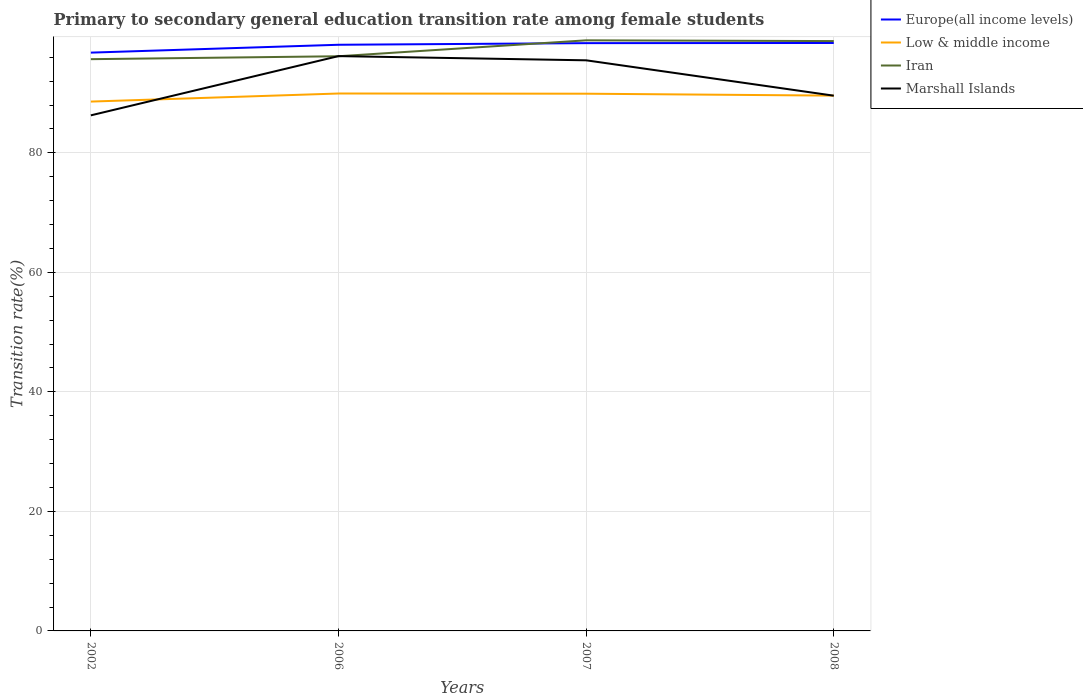How many different coloured lines are there?
Offer a very short reply. 4. Does the line corresponding to Marshall Islands intersect with the line corresponding to Low & middle income?
Keep it short and to the point. Yes. Across all years, what is the maximum transition rate in Marshall Islands?
Keep it short and to the point. 86.27. What is the total transition rate in Europe(all income levels) in the graph?
Offer a very short reply. -0.3. What is the difference between the highest and the second highest transition rate in Iran?
Give a very brief answer. 3.15. What is the difference between the highest and the lowest transition rate in Marshall Islands?
Your answer should be very brief. 2. Is the transition rate in Europe(all income levels) strictly greater than the transition rate in Iran over the years?
Your answer should be compact. No. How many years are there in the graph?
Offer a terse response. 4. Are the values on the major ticks of Y-axis written in scientific E-notation?
Give a very brief answer. No. How are the legend labels stacked?
Make the answer very short. Vertical. What is the title of the graph?
Provide a succinct answer. Primary to secondary general education transition rate among female students. What is the label or title of the Y-axis?
Provide a short and direct response. Transition rate(%). What is the Transition rate(%) in Europe(all income levels) in 2002?
Your answer should be compact. 96.77. What is the Transition rate(%) in Low & middle income in 2002?
Offer a terse response. 88.58. What is the Transition rate(%) of Iran in 2002?
Offer a very short reply. 95.68. What is the Transition rate(%) in Marshall Islands in 2002?
Provide a succinct answer. 86.27. What is the Transition rate(%) in Europe(all income levels) in 2006?
Offer a very short reply. 98.08. What is the Transition rate(%) in Low & middle income in 2006?
Keep it short and to the point. 89.93. What is the Transition rate(%) of Iran in 2006?
Give a very brief answer. 96.16. What is the Transition rate(%) in Marshall Islands in 2006?
Ensure brevity in your answer.  96.19. What is the Transition rate(%) of Europe(all income levels) in 2007?
Keep it short and to the point. 98.36. What is the Transition rate(%) in Low & middle income in 2007?
Keep it short and to the point. 89.89. What is the Transition rate(%) in Iran in 2007?
Your answer should be very brief. 98.83. What is the Transition rate(%) of Marshall Islands in 2007?
Your answer should be compact. 95.48. What is the Transition rate(%) of Europe(all income levels) in 2008?
Ensure brevity in your answer.  98.38. What is the Transition rate(%) in Low & middle income in 2008?
Your response must be concise. 89.58. What is the Transition rate(%) in Iran in 2008?
Offer a terse response. 98.7. What is the Transition rate(%) in Marshall Islands in 2008?
Provide a succinct answer. 89.57. Across all years, what is the maximum Transition rate(%) of Europe(all income levels)?
Your answer should be compact. 98.38. Across all years, what is the maximum Transition rate(%) of Low & middle income?
Keep it short and to the point. 89.93. Across all years, what is the maximum Transition rate(%) of Iran?
Provide a short and direct response. 98.83. Across all years, what is the maximum Transition rate(%) of Marshall Islands?
Your answer should be very brief. 96.19. Across all years, what is the minimum Transition rate(%) in Europe(all income levels)?
Your response must be concise. 96.77. Across all years, what is the minimum Transition rate(%) of Low & middle income?
Provide a short and direct response. 88.58. Across all years, what is the minimum Transition rate(%) in Iran?
Provide a short and direct response. 95.68. Across all years, what is the minimum Transition rate(%) of Marshall Islands?
Give a very brief answer. 86.27. What is the total Transition rate(%) in Europe(all income levels) in the graph?
Keep it short and to the point. 391.6. What is the total Transition rate(%) in Low & middle income in the graph?
Ensure brevity in your answer.  357.98. What is the total Transition rate(%) of Iran in the graph?
Offer a very short reply. 389.37. What is the total Transition rate(%) of Marshall Islands in the graph?
Offer a terse response. 367.51. What is the difference between the Transition rate(%) in Europe(all income levels) in 2002 and that in 2006?
Keep it short and to the point. -1.31. What is the difference between the Transition rate(%) in Low & middle income in 2002 and that in 2006?
Offer a terse response. -1.35. What is the difference between the Transition rate(%) in Iran in 2002 and that in 2006?
Offer a terse response. -0.49. What is the difference between the Transition rate(%) in Marshall Islands in 2002 and that in 2006?
Ensure brevity in your answer.  -9.91. What is the difference between the Transition rate(%) of Europe(all income levels) in 2002 and that in 2007?
Your answer should be very brief. -1.59. What is the difference between the Transition rate(%) in Low & middle income in 2002 and that in 2007?
Make the answer very short. -1.32. What is the difference between the Transition rate(%) in Iran in 2002 and that in 2007?
Keep it short and to the point. -3.15. What is the difference between the Transition rate(%) of Marshall Islands in 2002 and that in 2007?
Keep it short and to the point. -9.21. What is the difference between the Transition rate(%) in Europe(all income levels) in 2002 and that in 2008?
Provide a succinct answer. -1.61. What is the difference between the Transition rate(%) in Low & middle income in 2002 and that in 2008?
Give a very brief answer. -1. What is the difference between the Transition rate(%) of Iran in 2002 and that in 2008?
Offer a very short reply. -3.03. What is the difference between the Transition rate(%) of Marshall Islands in 2002 and that in 2008?
Your answer should be compact. -3.29. What is the difference between the Transition rate(%) of Europe(all income levels) in 2006 and that in 2007?
Your response must be concise. -0.27. What is the difference between the Transition rate(%) in Low & middle income in 2006 and that in 2007?
Provide a succinct answer. 0.03. What is the difference between the Transition rate(%) of Iran in 2006 and that in 2007?
Ensure brevity in your answer.  -2.66. What is the difference between the Transition rate(%) of Marshall Islands in 2006 and that in 2007?
Provide a succinct answer. 0.7. What is the difference between the Transition rate(%) of Europe(all income levels) in 2006 and that in 2008?
Your response must be concise. -0.3. What is the difference between the Transition rate(%) in Low & middle income in 2006 and that in 2008?
Make the answer very short. 0.35. What is the difference between the Transition rate(%) in Iran in 2006 and that in 2008?
Provide a short and direct response. -2.54. What is the difference between the Transition rate(%) in Marshall Islands in 2006 and that in 2008?
Give a very brief answer. 6.62. What is the difference between the Transition rate(%) of Europe(all income levels) in 2007 and that in 2008?
Offer a very short reply. -0.03. What is the difference between the Transition rate(%) of Low & middle income in 2007 and that in 2008?
Your answer should be compact. 0.32. What is the difference between the Transition rate(%) of Iran in 2007 and that in 2008?
Provide a succinct answer. 0.13. What is the difference between the Transition rate(%) in Marshall Islands in 2007 and that in 2008?
Offer a terse response. 5.92. What is the difference between the Transition rate(%) of Europe(all income levels) in 2002 and the Transition rate(%) of Low & middle income in 2006?
Your answer should be compact. 6.84. What is the difference between the Transition rate(%) of Europe(all income levels) in 2002 and the Transition rate(%) of Iran in 2006?
Ensure brevity in your answer.  0.61. What is the difference between the Transition rate(%) of Europe(all income levels) in 2002 and the Transition rate(%) of Marshall Islands in 2006?
Offer a terse response. 0.58. What is the difference between the Transition rate(%) of Low & middle income in 2002 and the Transition rate(%) of Iran in 2006?
Ensure brevity in your answer.  -7.59. What is the difference between the Transition rate(%) in Low & middle income in 2002 and the Transition rate(%) in Marshall Islands in 2006?
Your answer should be compact. -7.61. What is the difference between the Transition rate(%) in Iran in 2002 and the Transition rate(%) in Marshall Islands in 2006?
Provide a short and direct response. -0.51. What is the difference between the Transition rate(%) of Europe(all income levels) in 2002 and the Transition rate(%) of Low & middle income in 2007?
Your response must be concise. 6.87. What is the difference between the Transition rate(%) in Europe(all income levels) in 2002 and the Transition rate(%) in Iran in 2007?
Make the answer very short. -2.06. What is the difference between the Transition rate(%) in Europe(all income levels) in 2002 and the Transition rate(%) in Marshall Islands in 2007?
Provide a succinct answer. 1.28. What is the difference between the Transition rate(%) of Low & middle income in 2002 and the Transition rate(%) of Iran in 2007?
Provide a succinct answer. -10.25. What is the difference between the Transition rate(%) in Low & middle income in 2002 and the Transition rate(%) in Marshall Islands in 2007?
Provide a succinct answer. -6.91. What is the difference between the Transition rate(%) in Iran in 2002 and the Transition rate(%) in Marshall Islands in 2007?
Offer a very short reply. 0.19. What is the difference between the Transition rate(%) of Europe(all income levels) in 2002 and the Transition rate(%) of Low & middle income in 2008?
Keep it short and to the point. 7.19. What is the difference between the Transition rate(%) in Europe(all income levels) in 2002 and the Transition rate(%) in Iran in 2008?
Make the answer very short. -1.93. What is the difference between the Transition rate(%) of Europe(all income levels) in 2002 and the Transition rate(%) of Marshall Islands in 2008?
Make the answer very short. 7.2. What is the difference between the Transition rate(%) of Low & middle income in 2002 and the Transition rate(%) of Iran in 2008?
Your answer should be very brief. -10.12. What is the difference between the Transition rate(%) in Low & middle income in 2002 and the Transition rate(%) in Marshall Islands in 2008?
Provide a short and direct response. -0.99. What is the difference between the Transition rate(%) of Iran in 2002 and the Transition rate(%) of Marshall Islands in 2008?
Provide a succinct answer. 6.11. What is the difference between the Transition rate(%) of Europe(all income levels) in 2006 and the Transition rate(%) of Low & middle income in 2007?
Provide a short and direct response. 8.19. What is the difference between the Transition rate(%) of Europe(all income levels) in 2006 and the Transition rate(%) of Iran in 2007?
Offer a very short reply. -0.74. What is the difference between the Transition rate(%) of Europe(all income levels) in 2006 and the Transition rate(%) of Marshall Islands in 2007?
Make the answer very short. 2.6. What is the difference between the Transition rate(%) in Low & middle income in 2006 and the Transition rate(%) in Iran in 2007?
Ensure brevity in your answer.  -8.9. What is the difference between the Transition rate(%) in Low & middle income in 2006 and the Transition rate(%) in Marshall Islands in 2007?
Offer a very short reply. -5.56. What is the difference between the Transition rate(%) in Iran in 2006 and the Transition rate(%) in Marshall Islands in 2007?
Your response must be concise. 0.68. What is the difference between the Transition rate(%) of Europe(all income levels) in 2006 and the Transition rate(%) of Low & middle income in 2008?
Your answer should be very brief. 8.51. What is the difference between the Transition rate(%) of Europe(all income levels) in 2006 and the Transition rate(%) of Iran in 2008?
Keep it short and to the point. -0.62. What is the difference between the Transition rate(%) of Europe(all income levels) in 2006 and the Transition rate(%) of Marshall Islands in 2008?
Make the answer very short. 8.52. What is the difference between the Transition rate(%) of Low & middle income in 2006 and the Transition rate(%) of Iran in 2008?
Offer a very short reply. -8.77. What is the difference between the Transition rate(%) in Low & middle income in 2006 and the Transition rate(%) in Marshall Islands in 2008?
Make the answer very short. 0.36. What is the difference between the Transition rate(%) of Iran in 2006 and the Transition rate(%) of Marshall Islands in 2008?
Give a very brief answer. 6.6. What is the difference between the Transition rate(%) in Europe(all income levels) in 2007 and the Transition rate(%) in Low & middle income in 2008?
Give a very brief answer. 8.78. What is the difference between the Transition rate(%) in Europe(all income levels) in 2007 and the Transition rate(%) in Iran in 2008?
Make the answer very short. -0.35. What is the difference between the Transition rate(%) in Europe(all income levels) in 2007 and the Transition rate(%) in Marshall Islands in 2008?
Offer a terse response. 8.79. What is the difference between the Transition rate(%) in Low & middle income in 2007 and the Transition rate(%) in Iran in 2008?
Provide a succinct answer. -8.81. What is the difference between the Transition rate(%) of Low & middle income in 2007 and the Transition rate(%) of Marshall Islands in 2008?
Your answer should be compact. 0.33. What is the difference between the Transition rate(%) of Iran in 2007 and the Transition rate(%) of Marshall Islands in 2008?
Offer a very short reply. 9.26. What is the average Transition rate(%) in Europe(all income levels) per year?
Offer a terse response. 97.9. What is the average Transition rate(%) in Low & middle income per year?
Your response must be concise. 89.49. What is the average Transition rate(%) in Iran per year?
Keep it short and to the point. 97.34. What is the average Transition rate(%) in Marshall Islands per year?
Your answer should be compact. 91.88. In the year 2002, what is the difference between the Transition rate(%) in Europe(all income levels) and Transition rate(%) in Low & middle income?
Provide a succinct answer. 8.19. In the year 2002, what is the difference between the Transition rate(%) of Europe(all income levels) and Transition rate(%) of Iran?
Provide a short and direct response. 1.09. In the year 2002, what is the difference between the Transition rate(%) of Europe(all income levels) and Transition rate(%) of Marshall Islands?
Ensure brevity in your answer.  10.5. In the year 2002, what is the difference between the Transition rate(%) in Low & middle income and Transition rate(%) in Iran?
Ensure brevity in your answer.  -7.1. In the year 2002, what is the difference between the Transition rate(%) of Low & middle income and Transition rate(%) of Marshall Islands?
Your answer should be compact. 2.3. In the year 2002, what is the difference between the Transition rate(%) in Iran and Transition rate(%) in Marshall Islands?
Provide a succinct answer. 9.4. In the year 2006, what is the difference between the Transition rate(%) of Europe(all income levels) and Transition rate(%) of Low & middle income?
Your answer should be compact. 8.16. In the year 2006, what is the difference between the Transition rate(%) of Europe(all income levels) and Transition rate(%) of Iran?
Offer a very short reply. 1.92. In the year 2006, what is the difference between the Transition rate(%) in Europe(all income levels) and Transition rate(%) in Marshall Islands?
Offer a terse response. 1.9. In the year 2006, what is the difference between the Transition rate(%) of Low & middle income and Transition rate(%) of Iran?
Give a very brief answer. -6.24. In the year 2006, what is the difference between the Transition rate(%) in Low & middle income and Transition rate(%) in Marshall Islands?
Make the answer very short. -6.26. In the year 2006, what is the difference between the Transition rate(%) in Iran and Transition rate(%) in Marshall Islands?
Give a very brief answer. -0.02. In the year 2007, what is the difference between the Transition rate(%) in Europe(all income levels) and Transition rate(%) in Low & middle income?
Provide a short and direct response. 8.46. In the year 2007, what is the difference between the Transition rate(%) in Europe(all income levels) and Transition rate(%) in Iran?
Your response must be concise. -0.47. In the year 2007, what is the difference between the Transition rate(%) of Europe(all income levels) and Transition rate(%) of Marshall Islands?
Provide a succinct answer. 2.87. In the year 2007, what is the difference between the Transition rate(%) of Low & middle income and Transition rate(%) of Iran?
Your answer should be compact. -8.93. In the year 2007, what is the difference between the Transition rate(%) of Low & middle income and Transition rate(%) of Marshall Islands?
Keep it short and to the point. -5.59. In the year 2007, what is the difference between the Transition rate(%) of Iran and Transition rate(%) of Marshall Islands?
Your response must be concise. 3.34. In the year 2008, what is the difference between the Transition rate(%) in Europe(all income levels) and Transition rate(%) in Low & middle income?
Provide a short and direct response. 8.81. In the year 2008, what is the difference between the Transition rate(%) in Europe(all income levels) and Transition rate(%) in Iran?
Your answer should be compact. -0.32. In the year 2008, what is the difference between the Transition rate(%) of Europe(all income levels) and Transition rate(%) of Marshall Islands?
Keep it short and to the point. 8.82. In the year 2008, what is the difference between the Transition rate(%) of Low & middle income and Transition rate(%) of Iran?
Give a very brief answer. -9.13. In the year 2008, what is the difference between the Transition rate(%) in Low & middle income and Transition rate(%) in Marshall Islands?
Keep it short and to the point. 0.01. In the year 2008, what is the difference between the Transition rate(%) in Iran and Transition rate(%) in Marshall Islands?
Your answer should be very brief. 9.14. What is the ratio of the Transition rate(%) of Europe(all income levels) in 2002 to that in 2006?
Ensure brevity in your answer.  0.99. What is the ratio of the Transition rate(%) in Low & middle income in 2002 to that in 2006?
Make the answer very short. 0.98. What is the ratio of the Transition rate(%) in Iran in 2002 to that in 2006?
Your answer should be very brief. 0.99. What is the ratio of the Transition rate(%) of Marshall Islands in 2002 to that in 2006?
Your response must be concise. 0.9. What is the ratio of the Transition rate(%) of Europe(all income levels) in 2002 to that in 2007?
Keep it short and to the point. 0.98. What is the ratio of the Transition rate(%) in Low & middle income in 2002 to that in 2007?
Ensure brevity in your answer.  0.99. What is the ratio of the Transition rate(%) of Iran in 2002 to that in 2007?
Your response must be concise. 0.97. What is the ratio of the Transition rate(%) in Marshall Islands in 2002 to that in 2007?
Your answer should be compact. 0.9. What is the ratio of the Transition rate(%) of Europe(all income levels) in 2002 to that in 2008?
Your answer should be very brief. 0.98. What is the ratio of the Transition rate(%) in Low & middle income in 2002 to that in 2008?
Give a very brief answer. 0.99. What is the ratio of the Transition rate(%) of Iran in 2002 to that in 2008?
Keep it short and to the point. 0.97. What is the ratio of the Transition rate(%) in Marshall Islands in 2002 to that in 2008?
Make the answer very short. 0.96. What is the ratio of the Transition rate(%) of Low & middle income in 2006 to that in 2007?
Keep it short and to the point. 1. What is the ratio of the Transition rate(%) of Iran in 2006 to that in 2007?
Give a very brief answer. 0.97. What is the ratio of the Transition rate(%) in Marshall Islands in 2006 to that in 2007?
Your answer should be compact. 1.01. What is the ratio of the Transition rate(%) of Europe(all income levels) in 2006 to that in 2008?
Offer a very short reply. 1. What is the ratio of the Transition rate(%) of Iran in 2006 to that in 2008?
Provide a short and direct response. 0.97. What is the ratio of the Transition rate(%) in Marshall Islands in 2006 to that in 2008?
Make the answer very short. 1.07. What is the ratio of the Transition rate(%) in Europe(all income levels) in 2007 to that in 2008?
Provide a short and direct response. 1. What is the ratio of the Transition rate(%) in Low & middle income in 2007 to that in 2008?
Provide a succinct answer. 1. What is the ratio of the Transition rate(%) of Iran in 2007 to that in 2008?
Your answer should be compact. 1. What is the ratio of the Transition rate(%) of Marshall Islands in 2007 to that in 2008?
Offer a very short reply. 1.07. What is the difference between the highest and the second highest Transition rate(%) in Europe(all income levels)?
Ensure brevity in your answer.  0.03. What is the difference between the highest and the second highest Transition rate(%) in Low & middle income?
Your answer should be very brief. 0.03. What is the difference between the highest and the second highest Transition rate(%) of Iran?
Provide a short and direct response. 0.13. What is the difference between the highest and the second highest Transition rate(%) in Marshall Islands?
Provide a short and direct response. 0.7. What is the difference between the highest and the lowest Transition rate(%) of Europe(all income levels)?
Offer a terse response. 1.61. What is the difference between the highest and the lowest Transition rate(%) in Low & middle income?
Keep it short and to the point. 1.35. What is the difference between the highest and the lowest Transition rate(%) in Iran?
Your answer should be compact. 3.15. What is the difference between the highest and the lowest Transition rate(%) of Marshall Islands?
Provide a succinct answer. 9.91. 